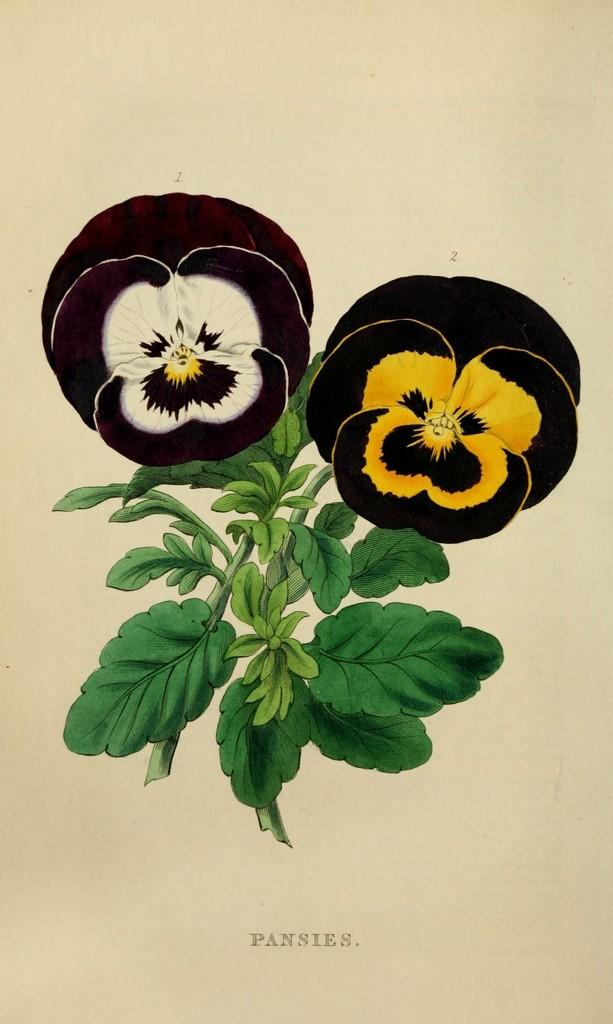What is present in the image that contains visual and written information? There is a poster in the image that contains images and text. Can you describe the content of the poster? The poster contains images and text, but the specific content cannot be determined from the provided facts. What type of ghost is depicted in the story on the poster? There is no story or ghost present in the image, as it only features a poster with images and text. 